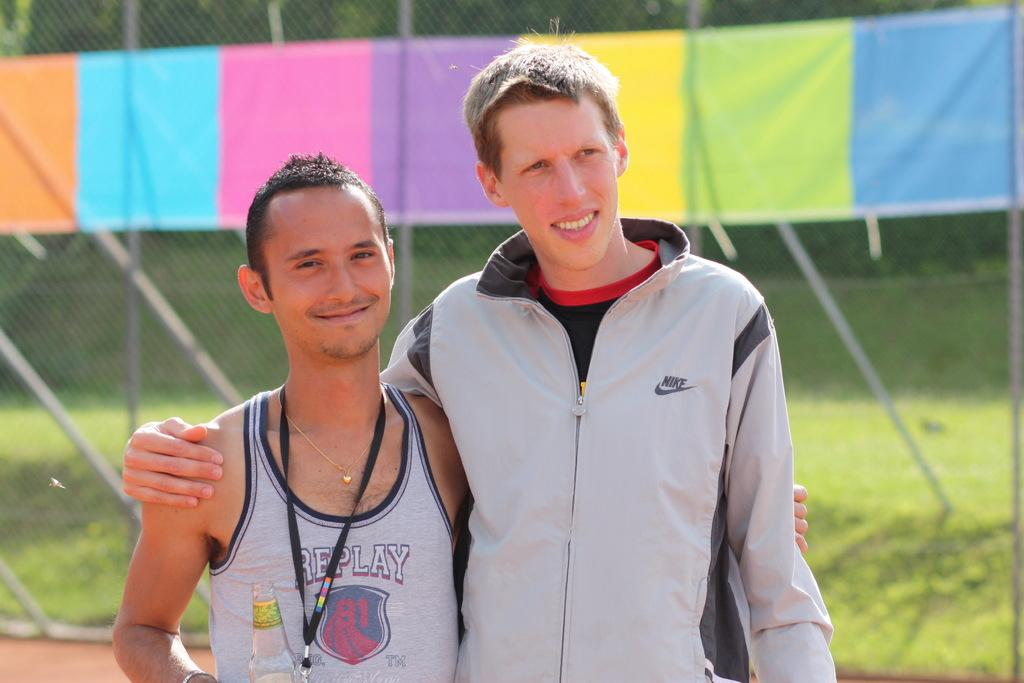Provide a one-sentence caption for the provided image. Two guys staning on a running track with the shorter one in a shirt that says replay. 